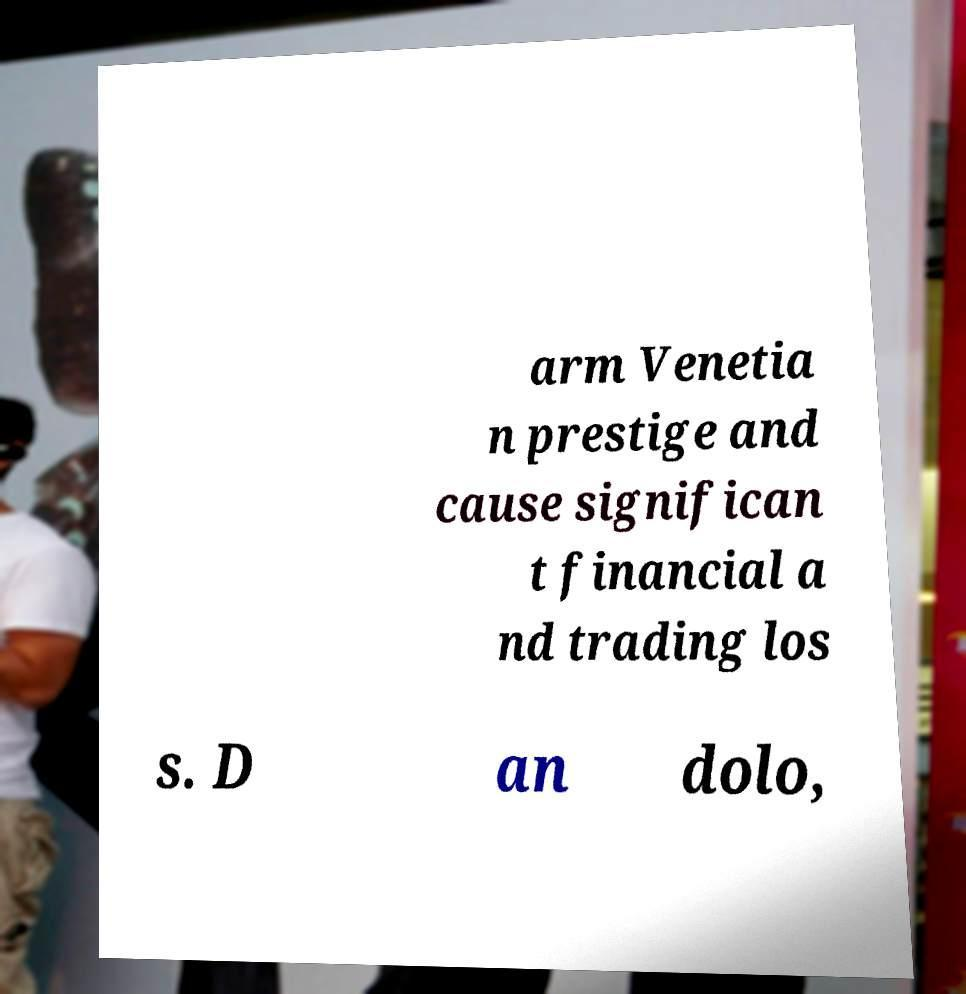There's text embedded in this image that I need extracted. Can you transcribe it verbatim? arm Venetia n prestige and cause significan t financial a nd trading los s. D an dolo, 